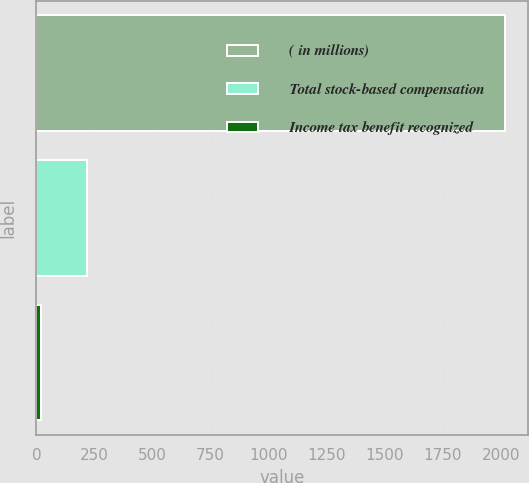Convert chart to OTSL. <chart><loc_0><loc_0><loc_500><loc_500><bar_chart><fcel>( in millions)<fcel>Total stock-based compensation<fcel>Income tax benefit recognized<nl><fcel>2015<fcel>218.6<fcel>19<nl></chart> 